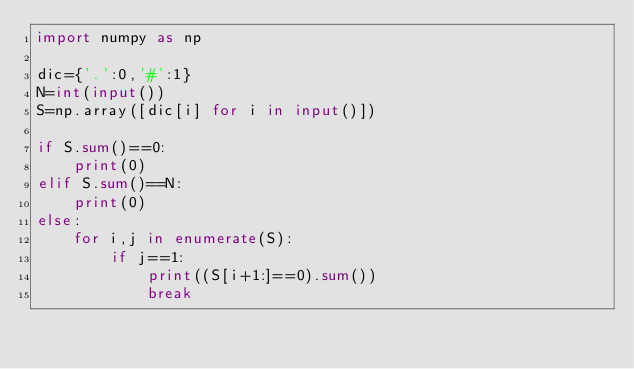Convert code to text. <code><loc_0><loc_0><loc_500><loc_500><_Python_>import numpy as np

dic={'.':0,'#':1}
N=int(input())
S=np.array([dic[i] for i in input()])

if S.sum()==0:
    print(0)
elif S.sum()==N:
    print(0)    
else:
    for i,j in enumerate(S):
        if j==1:
            print((S[i+1:]==0).sum())
            break</code> 